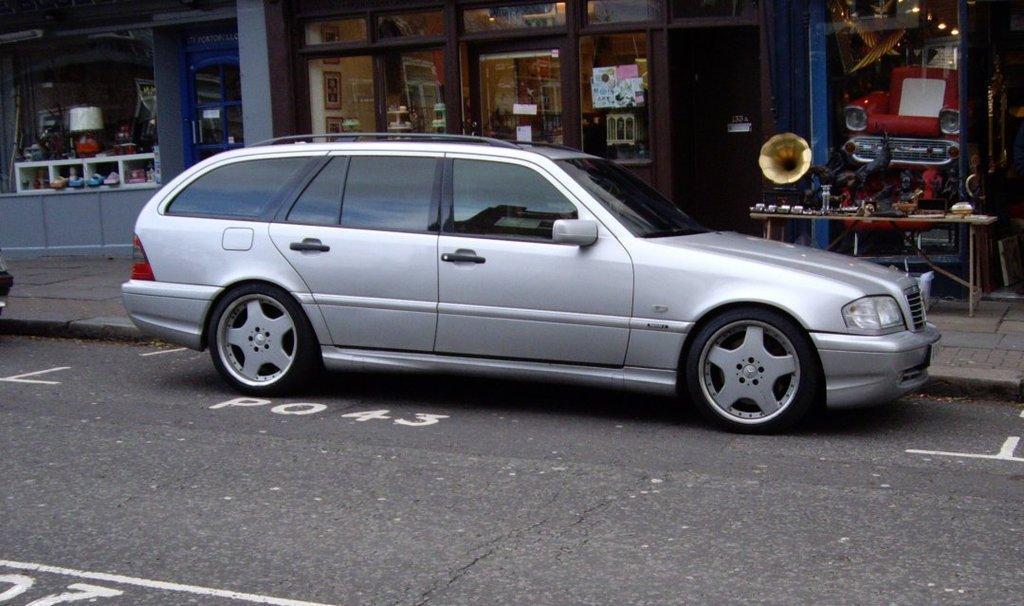Could you give a brief overview of what you see in this image? At the bottom, we see the road. In the middle, we see a car parked on the road. On the right side, we see a table on which the statues and the musical instruments are placed. Behind that, we see a building in brown color. We see the posters pasted on the glass doors. We see a wall on which the photo frames are placed. On the left side, we see a building in grey color. We see a lamp and some other objects. We see a woman is sitting on the chair. 